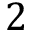Convert formula to latex. <formula><loc_0><loc_0><loc_500><loc_500>2</formula> 